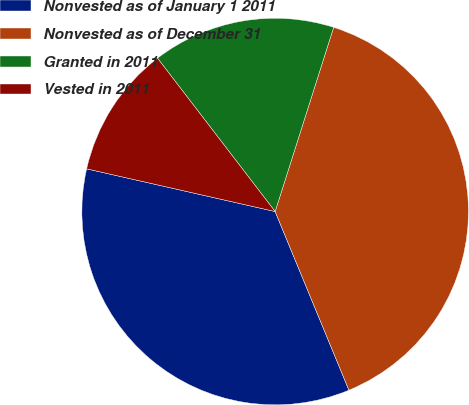Convert chart to OTSL. <chart><loc_0><loc_0><loc_500><loc_500><pie_chart><fcel>Nonvested as of January 1 2011<fcel>Nonvested as of December 31<fcel>Granted in 2011<fcel>Vested in 2011<nl><fcel>34.78%<fcel>38.87%<fcel>15.31%<fcel>11.04%<nl></chart> 